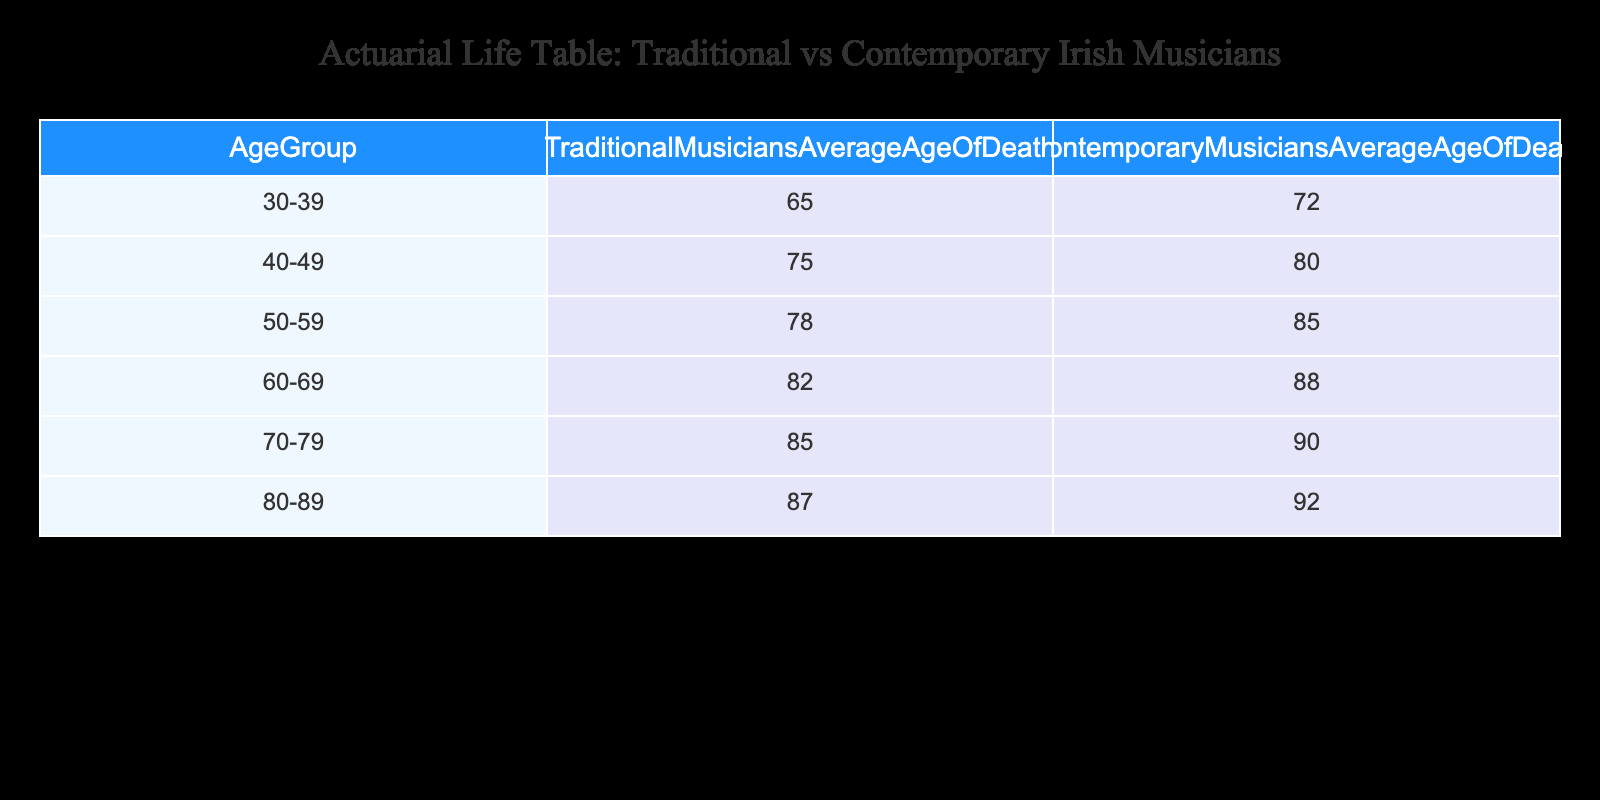What is the average age of death for traditional musicians in the 40-49 age group? According to the table, the average age of death for traditional musicians in the 40-49 age group is specifically listed as 75.
Answer: 75 What is the average age of death for contemporary musicians in the 60-69 age group? The table shows that the average age of death for contemporary musicians in the 60-69 age group is 88.
Answer: 88 Which age group has the largest difference in average age of death between traditional and contemporary musicians? To find the largest difference, we compare the differences in each age group: 30-39: 7, 40-49: 5, 50-59: 7, 60-69: 6, 70-79: 5, 80-89: 5. The largest difference of 7 is in both the 30-39 and 50-59 age groups.
Answer: 30-39 and 50-59 Is the average age of death for contemporary musicians higher than that of traditional musicians across all age groups? By examining the table, we find that in all age groups, the average age of death for contemporary musicians is consistently higher than that of traditional musicians, confirming that this statement is true.
Answer: Yes What is the average age of death for traditional musicians across all age groups? To calculate the average age of death, we sum the average ages: (65 + 75 + 78 + 82 + 85 + 87) = 472, and divide by the number of age groups, which is 6. So, 472/6 = 78.67.
Answer: 78.67 What is the median average age of death for contemporary musicians? First, we list the average ages for contemporary musicians: 72, 80, 85, 88, 90, 92. The median is the average of the two middle numbers. Since there are 6 numbers (80 and 85 are the middle two), (80 + 85) / 2 = 82.5.
Answer: 82.5 Which age group has the highest average age of death for traditional musicians? By checking the table, we see that the 80-89 age group has the highest average age of death for traditional musicians, listed as 87.
Answer: 80-89 Do traditional musicians in the age group 70-79 live longer on average than contemporary musicians in the same age group? The average age of death for traditional musicians in the 70-79 age group is 85, while for contemporary musicians it is 90. Since 85 is less than 90, traditional musicians do not live longer on average than contemporary musicians in this age group.
Answer: No 